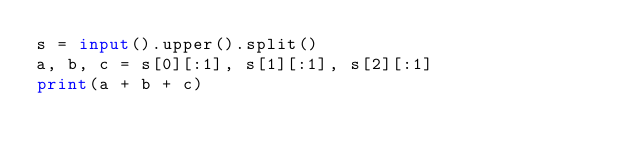Convert code to text. <code><loc_0><loc_0><loc_500><loc_500><_Python_>s = input().upper().split()
a, b, c = s[0][:1], s[1][:1], s[2][:1]
print(a + b + c)</code> 